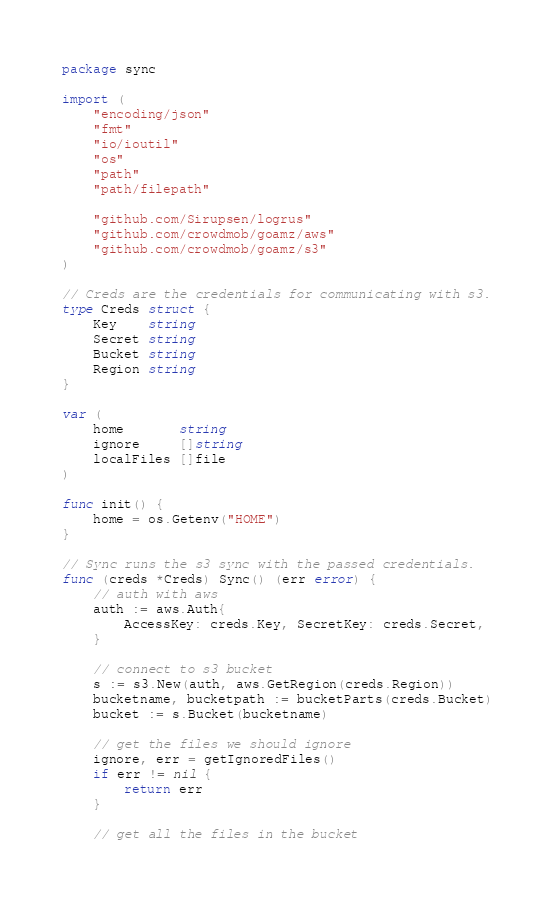Convert code to text. <code><loc_0><loc_0><loc_500><loc_500><_Go_>package sync

import (
	"encoding/json"
	"fmt"
	"io/ioutil"
	"os"
	"path"
	"path/filepath"

	"github.com/Sirupsen/logrus"
	"github.com/crowdmob/goamz/aws"
	"github.com/crowdmob/goamz/s3"
)

// Creds are the credentials for communicating with s3.
type Creds struct {
	Key    string
	Secret string
	Bucket string
	Region string
}

var (
	home       string
	ignore     []string
	localFiles []file
)

func init() {
	home = os.Getenv("HOME")
}

// Sync runs the s3 sync with the passed credentials.
func (creds *Creds) Sync() (err error) {
	// auth with aws
	auth := aws.Auth{
		AccessKey: creds.Key, SecretKey: creds.Secret,
	}

	// connect to s3 bucket
	s := s3.New(auth, aws.GetRegion(creds.Region))
	bucketname, bucketpath := bucketParts(creds.Bucket)
	bucket := s.Bucket(bucketname)

	// get the files we should ignore
	ignore, err = getIgnoredFiles()
	if err != nil {
		return err
	}

	// get all the files in the bucket</code> 